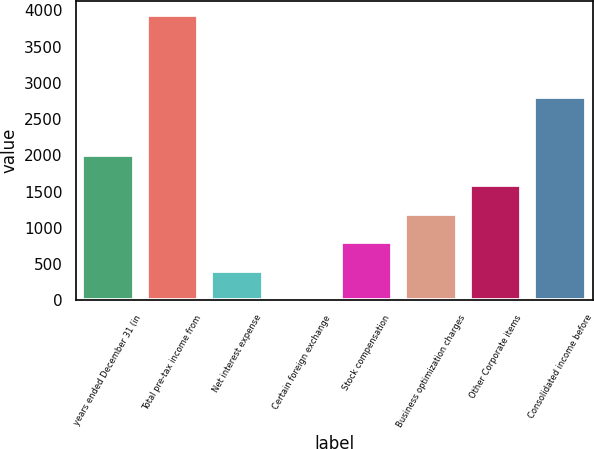<chart> <loc_0><loc_0><loc_500><loc_500><bar_chart><fcel>years ended December 31 (in<fcel>Total pre-tax income from<fcel>Net interest expense<fcel>Certain foreign exchange<fcel>Stock compensation<fcel>Business optimization charges<fcel>Other Corporate items<fcel>Consolidated income before<nl><fcel>2011<fcel>3938<fcel>408.2<fcel>16<fcel>800.4<fcel>1192.6<fcel>1584.8<fcel>2809<nl></chart> 